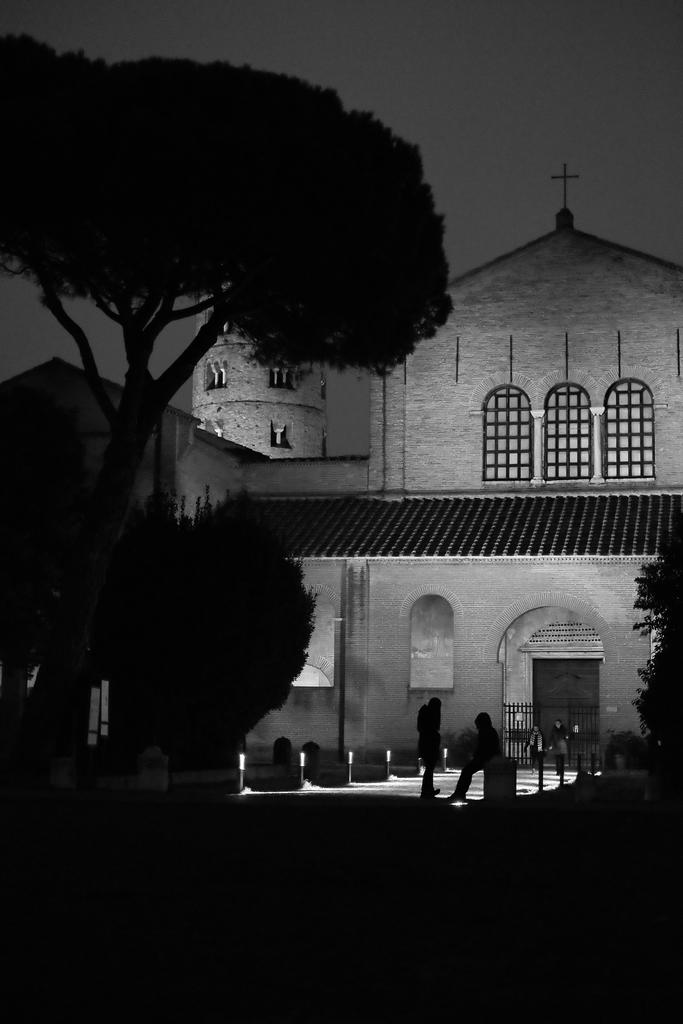What type of structure is present in the image? There is a building in the image. What can be seen illuminated in the image? There are lights visible in the image. What type of vegetation is present in the image? There are plants and trees in the image. What is visible in the background of the image? The sky is visible in the background of the image. What type of dress is hanging on the tree in the image? There is no dress present in the image; it features a building, lights, plants, trees, and the sky. 